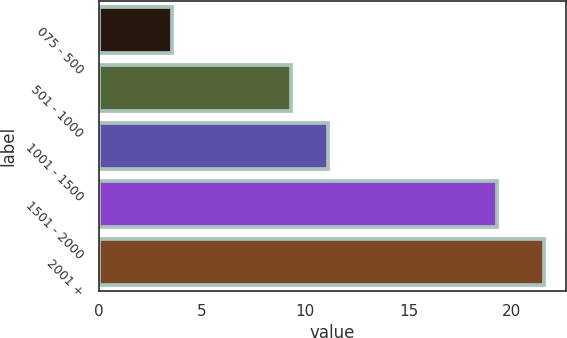Convert chart. <chart><loc_0><loc_0><loc_500><loc_500><bar_chart><fcel>075 - 500<fcel>501 - 1000<fcel>1001 - 1500<fcel>1501 - 2000<fcel>2001 +<nl><fcel>3.53<fcel>9.32<fcel>11.12<fcel>19.26<fcel>21.56<nl></chart> 